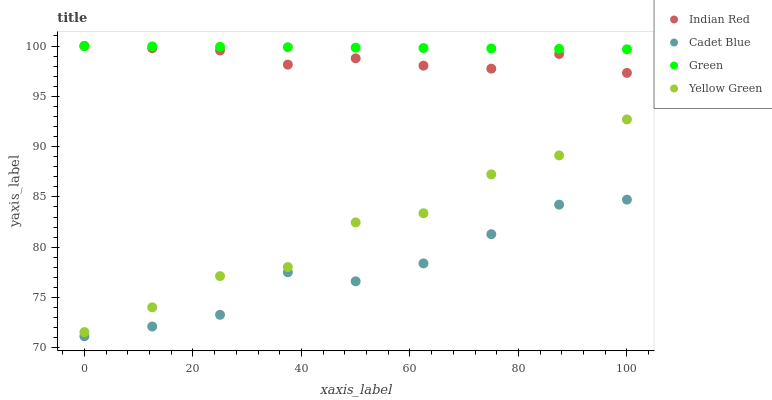Does Cadet Blue have the minimum area under the curve?
Answer yes or no. Yes. Does Green have the maximum area under the curve?
Answer yes or no. Yes. Does Yellow Green have the minimum area under the curve?
Answer yes or no. No. Does Yellow Green have the maximum area under the curve?
Answer yes or no. No. Is Green the smoothest?
Answer yes or no. Yes. Is Yellow Green the roughest?
Answer yes or no. Yes. Is Yellow Green the smoothest?
Answer yes or no. No. Is Green the roughest?
Answer yes or no. No. Does Cadet Blue have the lowest value?
Answer yes or no. Yes. Does Yellow Green have the lowest value?
Answer yes or no. No. Does Indian Red have the highest value?
Answer yes or no. Yes. Does Yellow Green have the highest value?
Answer yes or no. No. Is Yellow Green less than Indian Red?
Answer yes or no. Yes. Is Green greater than Cadet Blue?
Answer yes or no. Yes. Does Green intersect Indian Red?
Answer yes or no. Yes. Is Green less than Indian Red?
Answer yes or no. No. Is Green greater than Indian Red?
Answer yes or no. No. Does Yellow Green intersect Indian Red?
Answer yes or no. No. 